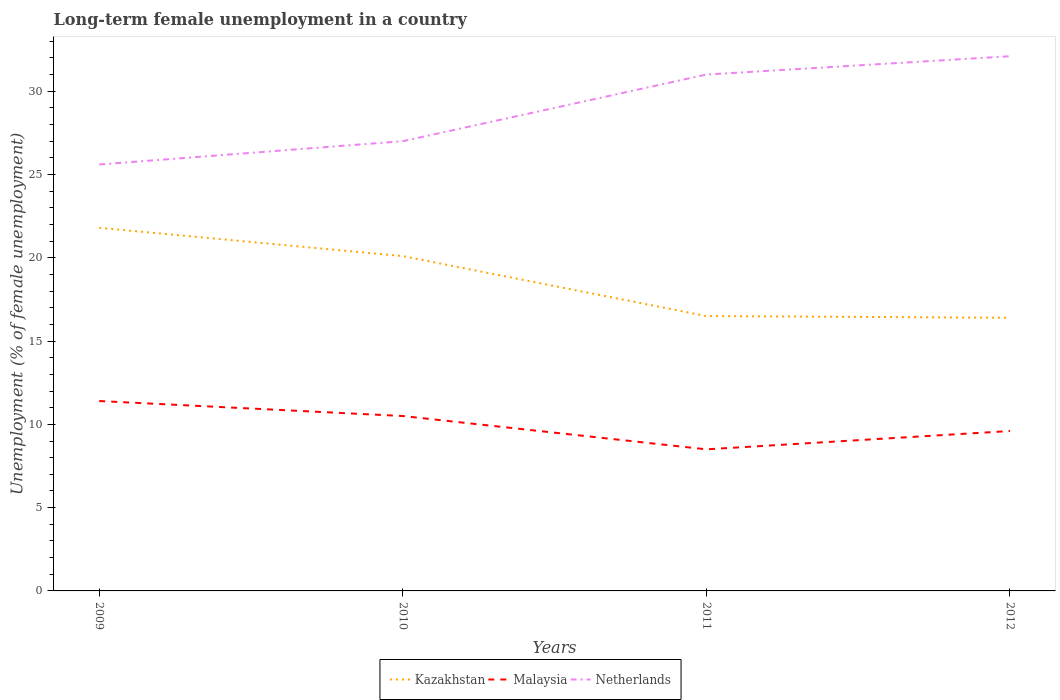Across all years, what is the maximum percentage of long-term unemployed female population in Kazakhstan?
Provide a short and direct response. 16.4. What is the total percentage of long-term unemployed female population in Malaysia in the graph?
Make the answer very short. 2.9. What is the difference between the highest and the second highest percentage of long-term unemployed female population in Kazakhstan?
Offer a terse response. 5.4. Is the percentage of long-term unemployed female population in Malaysia strictly greater than the percentage of long-term unemployed female population in Kazakhstan over the years?
Ensure brevity in your answer.  Yes. How many lines are there?
Your answer should be compact. 3. How many years are there in the graph?
Offer a terse response. 4. What is the difference between two consecutive major ticks on the Y-axis?
Your answer should be compact. 5. Does the graph contain grids?
Your response must be concise. No. How many legend labels are there?
Your response must be concise. 3. What is the title of the graph?
Offer a very short reply. Long-term female unemployment in a country. What is the label or title of the Y-axis?
Your answer should be very brief. Unemployment (% of female unemployment). What is the Unemployment (% of female unemployment) of Kazakhstan in 2009?
Your answer should be very brief. 21.8. What is the Unemployment (% of female unemployment) in Malaysia in 2009?
Provide a short and direct response. 11.4. What is the Unemployment (% of female unemployment) in Netherlands in 2009?
Make the answer very short. 25.6. What is the Unemployment (% of female unemployment) of Kazakhstan in 2010?
Provide a succinct answer. 20.1. What is the Unemployment (% of female unemployment) of Netherlands in 2011?
Provide a succinct answer. 31. What is the Unemployment (% of female unemployment) of Kazakhstan in 2012?
Your answer should be very brief. 16.4. What is the Unemployment (% of female unemployment) in Malaysia in 2012?
Your response must be concise. 9.6. What is the Unemployment (% of female unemployment) in Netherlands in 2012?
Offer a terse response. 32.1. Across all years, what is the maximum Unemployment (% of female unemployment) in Kazakhstan?
Your answer should be compact. 21.8. Across all years, what is the maximum Unemployment (% of female unemployment) in Malaysia?
Your answer should be very brief. 11.4. Across all years, what is the maximum Unemployment (% of female unemployment) in Netherlands?
Your answer should be compact. 32.1. Across all years, what is the minimum Unemployment (% of female unemployment) of Kazakhstan?
Give a very brief answer. 16.4. Across all years, what is the minimum Unemployment (% of female unemployment) in Malaysia?
Your answer should be very brief. 8.5. Across all years, what is the minimum Unemployment (% of female unemployment) of Netherlands?
Keep it short and to the point. 25.6. What is the total Unemployment (% of female unemployment) in Kazakhstan in the graph?
Your answer should be very brief. 74.8. What is the total Unemployment (% of female unemployment) of Netherlands in the graph?
Your answer should be very brief. 115.7. What is the difference between the Unemployment (% of female unemployment) of Kazakhstan in 2009 and that in 2010?
Give a very brief answer. 1.7. What is the difference between the Unemployment (% of female unemployment) in Malaysia in 2009 and that in 2010?
Your response must be concise. 0.9. What is the difference between the Unemployment (% of female unemployment) of Kazakhstan in 2009 and that in 2012?
Offer a terse response. 5.4. What is the difference between the Unemployment (% of female unemployment) of Malaysia in 2009 and that in 2012?
Provide a short and direct response. 1.8. What is the difference between the Unemployment (% of female unemployment) of Netherlands in 2009 and that in 2012?
Keep it short and to the point. -6.5. What is the difference between the Unemployment (% of female unemployment) in Kazakhstan in 2010 and that in 2011?
Your answer should be very brief. 3.6. What is the difference between the Unemployment (% of female unemployment) in Malaysia in 2010 and that in 2011?
Your answer should be compact. 2. What is the difference between the Unemployment (% of female unemployment) in Kazakhstan in 2010 and that in 2012?
Keep it short and to the point. 3.7. What is the difference between the Unemployment (% of female unemployment) of Netherlands in 2010 and that in 2012?
Offer a terse response. -5.1. What is the difference between the Unemployment (% of female unemployment) of Malaysia in 2011 and that in 2012?
Offer a terse response. -1.1. What is the difference between the Unemployment (% of female unemployment) in Malaysia in 2009 and the Unemployment (% of female unemployment) in Netherlands in 2010?
Your answer should be very brief. -15.6. What is the difference between the Unemployment (% of female unemployment) in Malaysia in 2009 and the Unemployment (% of female unemployment) in Netherlands in 2011?
Your answer should be very brief. -19.6. What is the difference between the Unemployment (% of female unemployment) of Kazakhstan in 2009 and the Unemployment (% of female unemployment) of Malaysia in 2012?
Ensure brevity in your answer.  12.2. What is the difference between the Unemployment (% of female unemployment) of Malaysia in 2009 and the Unemployment (% of female unemployment) of Netherlands in 2012?
Ensure brevity in your answer.  -20.7. What is the difference between the Unemployment (% of female unemployment) in Kazakhstan in 2010 and the Unemployment (% of female unemployment) in Netherlands in 2011?
Your answer should be very brief. -10.9. What is the difference between the Unemployment (% of female unemployment) in Malaysia in 2010 and the Unemployment (% of female unemployment) in Netherlands in 2011?
Keep it short and to the point. -20.5. What is the difference between the Unemployment (% of female unemployment) in Kazakhstan in 2010 and the Unemployment (% of female unemployment) in Netherlands in 2012?
Provide a short and direct response. -12. What is the difference between the Unemployment (% of female unemployment) in Malaysia in 2010 and the Unemployment (% of female unemployment) in Netherlands in 2012?
Offer a terse response. -21.6. What is the difference between the Unemployment (% of female unemployment) in Kazakhstan in 2011 and the Unemployment (% of female unemployment) in Malaysia in 2012?
Your response must be concise. 6.9. What is the difference between the Unemployment (% of female unemployment) of Kazakhstan in 2011 and the Unemployment (% of female unemployment) of Netherlands in 2012?
Make the answer very short. -15.6. What is the difference between the Unemployment (% of female unemployment) of Malaysia in 2011 and the Unemployment (% of female unemployment) of Netherlands in 2012?
Your answer should be very brief. -23.6. What is the average Unemployment (% of female unemployment) in Malaysia per year?
Offer a very short reply. 10. What is the average Unemployment (% of female unemployment) of Netherlands per year?
Keep it short and to the point. 28.93. In the year 2009, what is the difference between the Unemployment (% of female unemployment) in Malaysia and Unemployment (% of female unemployment) in Netherlands?
Your answer should be very brief. -14.2. In the year 2010, what is the difference between the Unemployment (% of female unemployment) of Kazakhstan and Unemployment (% of female unemployment) of Malaysia?
Your answer should be very brief. 9.6. In the year 2010, what is the difference between the Unemployment (% of female unemployment) of Malaysia and Unemployment (% of female unemployment) of Netherlands?
Ensure brevity in your answer.  -16.5. In the year 2011, what is the difference between the Unemployment (% of female unemployment) in Kazakhstan and Unemployment (% of female unemployment) in Malaysia?
Offer a terse response. 8. In the year 2011, what is the difference between the Unemployment (% of female unemployment) of Kazakhstan and Unemployment (% of female unemployment) of Netherlands?
Make the answer very short. -14.5. In the year 2011, what is the difference between the Unemployment (% of female unemployment) in Malaysia and Unemployment (% of female unemployment) in Netherlands?
Ensure brevity in your answer.  -22.5. In the year 2012, what is the difference between the Unemployment (% of female unemployment) in Kazakhstan and Unemployment (% of female unemployment) in Netherlands?
Offer a terse response. -15.7. In the year 2012, what is the difference between the Unemployment (% of female unemployment) of Malaysia and Unemployment (% of female unemployment) of Netherlands?
Offer a terse response. -22.5. What is the ratio of the Unemployment (% of female unemployment) in Kazakhstan in 2009 to that in 2010?
Keep it short and to the point. 1.08. What is the ratio of the Unemployment (% of female unemployment) of Malaysia in 2009 to that in 2010?
Provide a short and direct response. 1.09. What is the ratio of the Unemployment (% of female unemployment) of Netherlands in 2009 to that in 2010?
Provide a succinct answer. 0.95. What is the ratio of the Unemployment (% of female unemployment) in Kazakhstan in 2009 to that in 2011?
Ensure brevity in your answer.  1.32. What is the ratio of the Unemployment (% of female unemployment) of Malaysia in 2009 to that in 2011?
Provide a short and direct response. 1.34. What is the ratio of the Unemployment (% of female unemployment) of Netherlands in 2009 to that in 2011?
Make the answer very short. 0.83. What is the ratio of the Unemployment (% of female unemployment) of Kazakhstan in 2009 to that in 2012?
Your answer should be very brief. 1.33. What is the ratio of the Unemployment (% of female unemployment) in Malaysia in 2009 to that in 2012?
Your answer should be very brief. 1.19. What is the ratio of the Unemployment (% of female unemployment) of Netherlands in 2009 to that in 2012?
Provide a succinct answer. 0.8. What is the ratio of the Unemployment (% of female unemployment) in Kazakhstan in 2010 to that in 2011?
Offer a terse response. 1.22. What is the ratio of the Unemployment (% of female unemployment) of Malaysia in 2010 to that in 2011?
Offer a terse response. 1.24. What is the ratio of the Unemployment (% of female unemployment) in Netherlands in 2010 to that in 2011?
Offer a terse response. 0.87. What is the ratio of the Unemployment (% of female unemployment) in Kazakhstan in 2010 to that in 2012?
Give a very brief answer. 1.23. What is the ratio of the Unemployment (% of female unemployment) in Malaysia in 2010 to that in 2012?
Your answer should be very brief. 1.09. What is the ratio of the Unemployment (% of female unemployment) in Netherlands in 2010 to that in 2012?
Give a very brief answer. 0.84. What is the ratio of the Unemployment (% of female unemployment) of Malaysia in 2011 to that in 2012?
Give a very brief answer. 0.89. What is the ratio of the Unemployment (% of female unemployment) of Netherlands in 2011 to that in 2012?
Provide a short and direct response. 0.97. What is the difference between the highest and the second highest Unemployment (% of female unemployment) of Malaysia?
Make the answer very short. 0.9. What is the difference between the highest and the lowest Unemployment (% of female unemployment) in Malaysia?
Provide a short and direct response. 2.9. What is the difference between the highest and the lowest Unemployment (% of female unemployment) of Netherlands?
Ensure brevity in your answer.  6.5. 